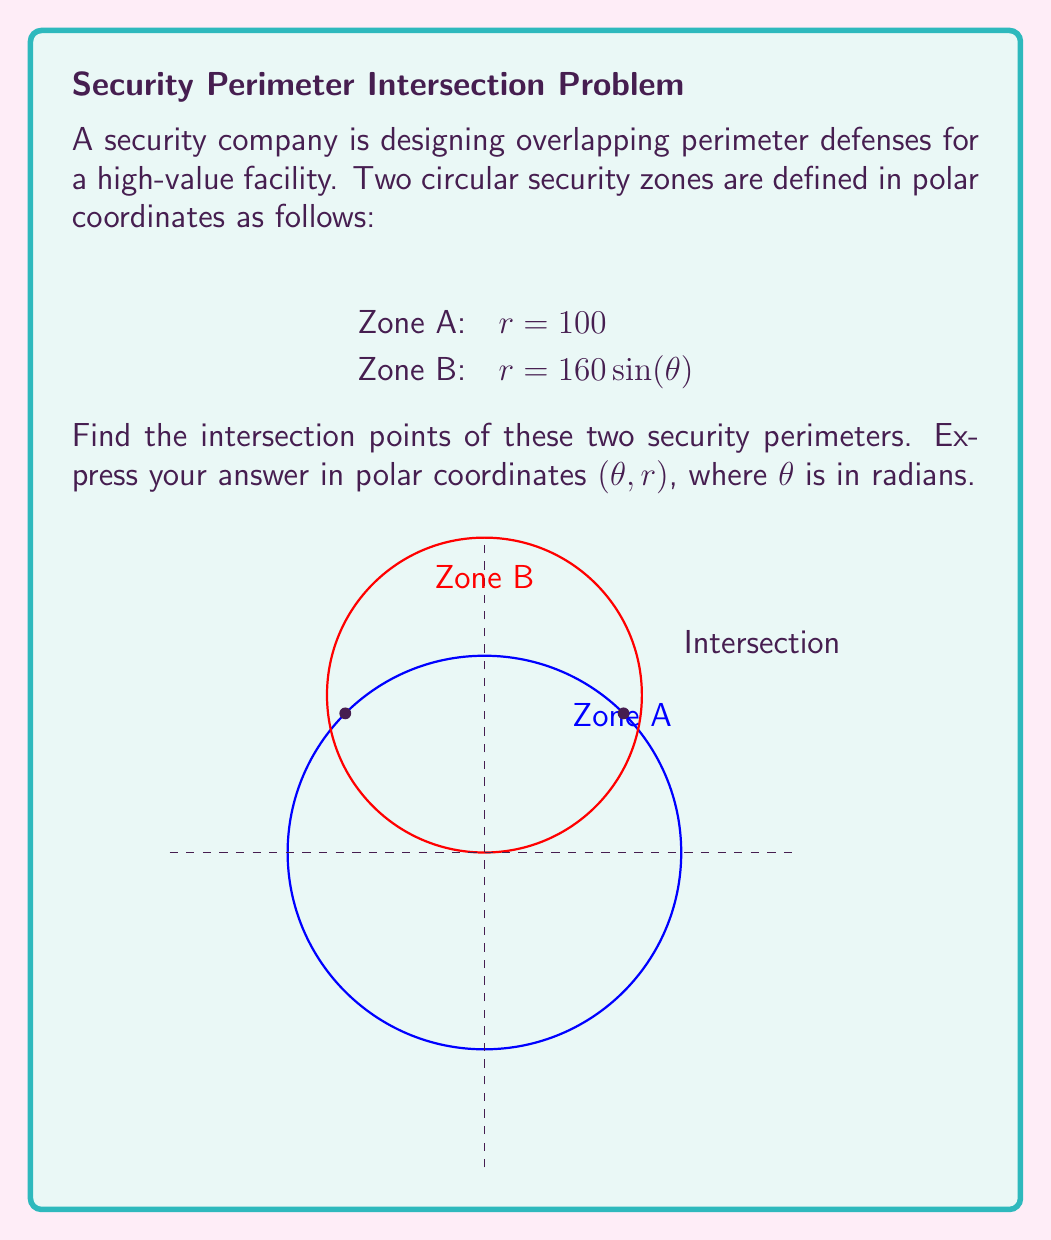Could you help me with this problem? To find the intersection points, we need to solve the equation where the two functions are equal:

1) Set the equations equal to each other:
   $100 = 160 \sin(\theta)$

2) Solve for $\sin(\theta)$:
   $\sin(\theta) = \frac{100}{160} = \frac{5}{8}$

3) Take the inverse sine (arcsin) of both sides:
   $\theta = \arcsin(\frac{5}{8})$ or $\theta = \pi - \arcsin(\frac{5}{8})$

4) Calculate the values:
   $\theta_1 = \arcsin(\frac{5}{8}) \approx 0.6435$ radians
   $\theta_2 = \pi - \arcsin(\frac{5}{8}) \approx 2.4981$ radians

5) The r-coordinate for both points is 100, as they lie on Zone A's perimeter.

Therefore, the intersection points in polar coordinates $(\theta, r)$ are:
$$(0.6435, 100) \text{ and } (2.4981, 100)$$

These points represent the locations where the two security perimeters overlap, which are critical for ensuring complete coverage and identifying potential vulnerabilities in the security system.
Answer: $(0.6435, 100)$ and $(2.4981, 100)$ 